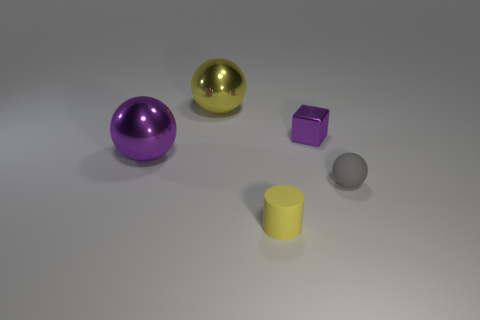Subtract all large purple shiny spheres. How many spheres are left? 2 Add 2 purple objects. How many objects exist? 7 Subtract 1 balls. How many balls are left? 2 Subtract all cubes. How many objects are left? 4 Subtract all yellow spheres. How many spheres are left? 2 Subtract all gray blocks. How many gray spheres are left? 1 Add 5 purple blocks. How many purple blocks exist? 6 Subtract 0 red cylinders. How many objects are left? 5 Subtract all red cylinders. Subtract all green spheres. How many cylinders are left? 1 Subtract all yellow shiny things. Subtract all tiny purple cylinders. How many objects are left? 4 